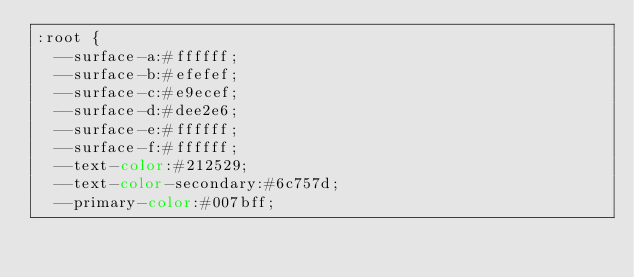<code> <loc_0><loc_0><loc_500><loc_500><_CSS_>:root {
  --surface-a:#ffffff;
  --surface-b:#efefef;
  --surface-c:#e9ecef;
  --surface-d:#dee2e6;
  --surface-e:#ffffff;
  --surface-f:#ffffff;
  --text-color:#212529;
  --text-color-secondary:#6c757d;
  --primary-color:#007bff;</code> 